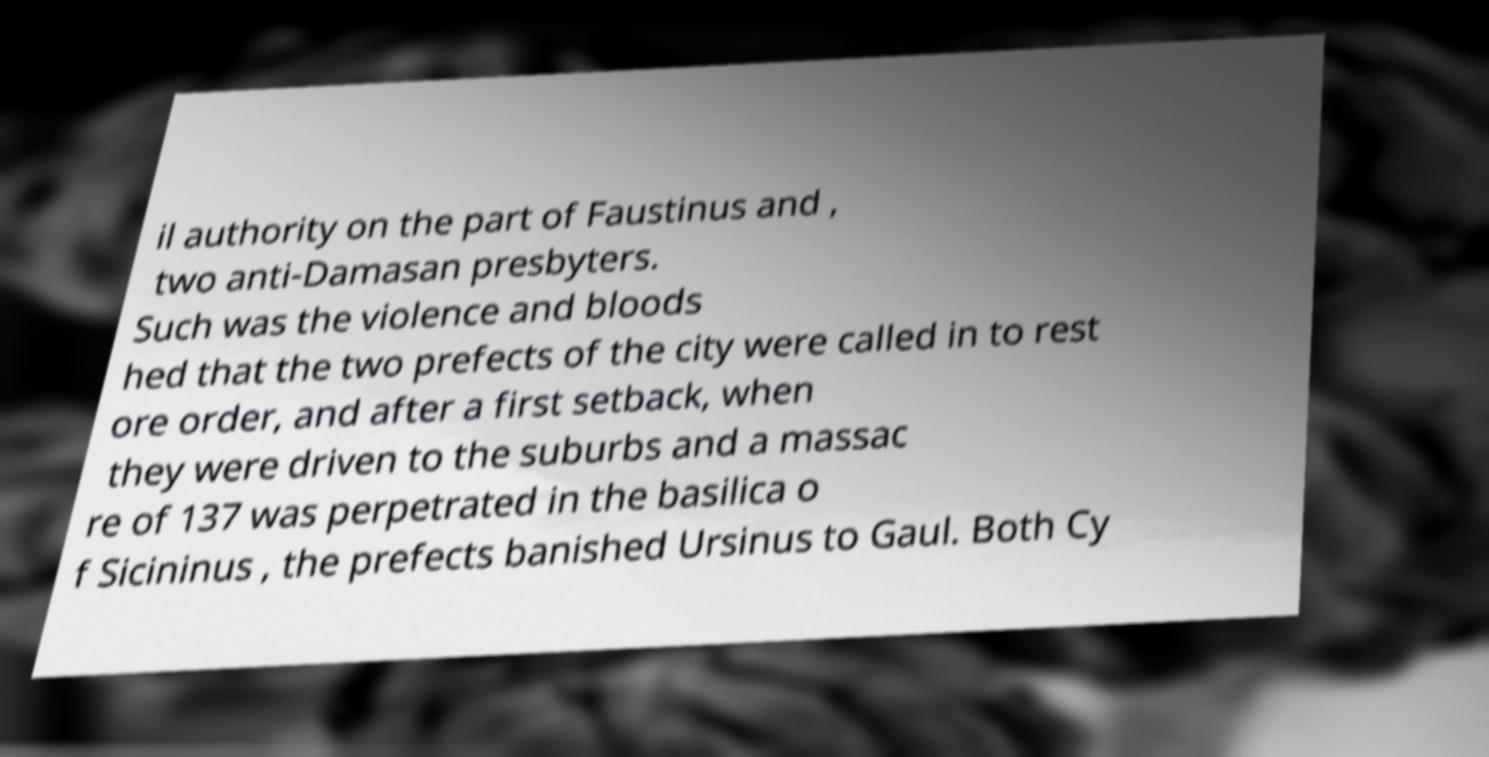What messages or text are displayed in this image? I need them in a readable, typed format. il authority on the part of Faustinus and , two anti-Damasan presbyters. Such was the violence and bloods hed that the two prefects of the city were called in to rest ore order, and after a first setback, when they were driven to the suburbs and a massac re of 137 was perpetrated in the basilica o f Sicininus , the prefects banished Ursinus to Gaul. Both Cy 